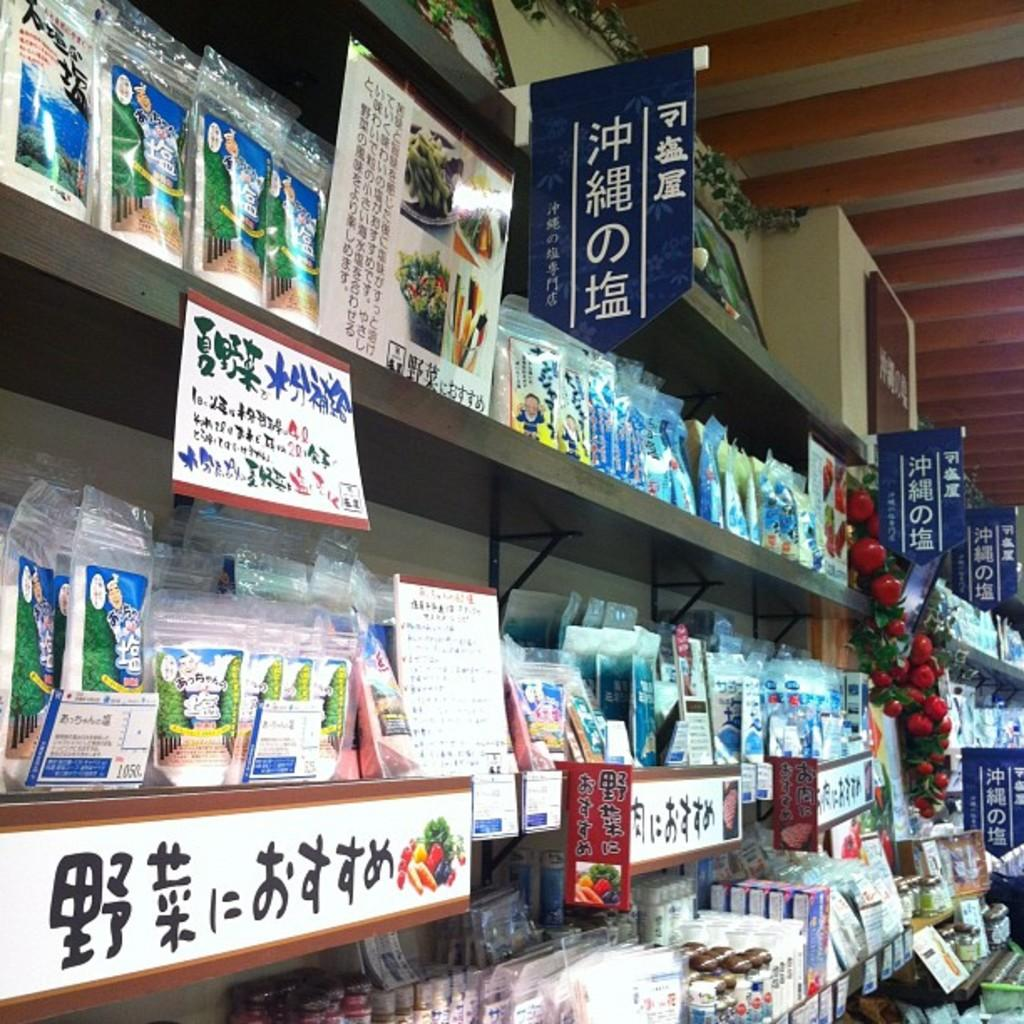<image>
Present a compact description of the photo's key features. A store contains a collection of products with Asian writing on them. 